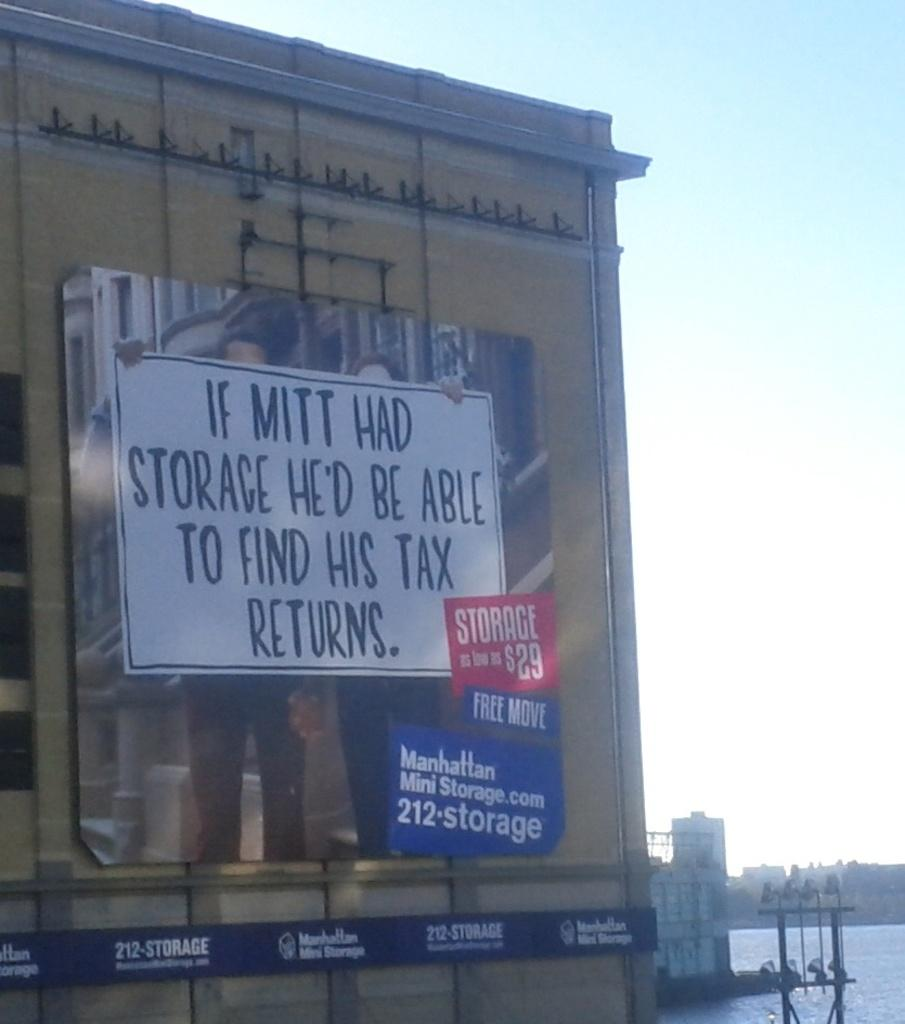<image>
Relay a brief, clear account of the picture shown. A giant building has a sign that says If Mitt Had Storage He'd Be Able To Find His Tax Returns. 